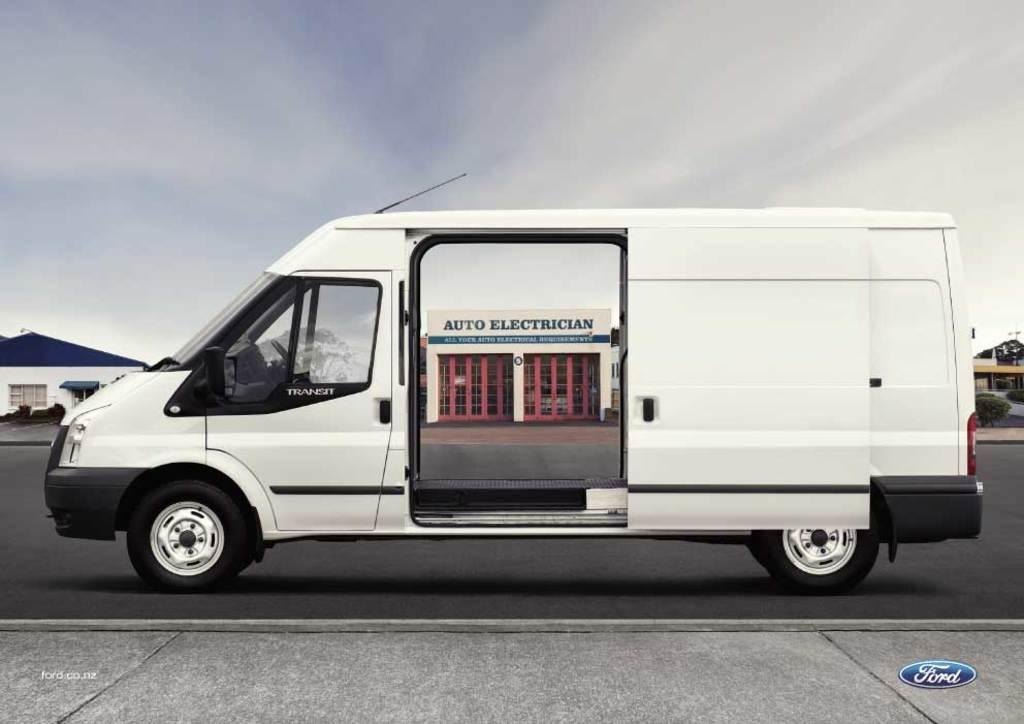<image>
Give a short and clear explanation of the subsequent image. A white van says Transit and has both sliding doors open. 